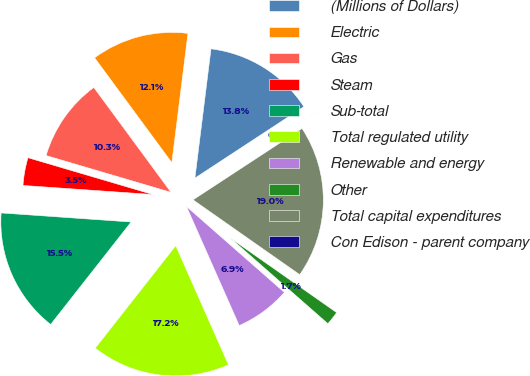Convert chart. <chart><loc_0><loc_0><loc_500><loc_500><pie_chart><fcel>(Millions of Dollars)<fcel>Electric<fcel>Gas<fcel>Steam<fcel>Sub-total<fcel>Total regulated utility<fcel>Renewable and energy<fcel>Other<fcel>Total capital expenditures<fcel>Con Edison - parent company<nl><fcel>13.79%<fcel>12.07%<fcel>10.34%<fcel>3.45%<fcel>15.51%<fcel>17.23%<fcel>6.9%<fcel>1.73%<fcel>18.96%<fcel>0.01%<nl></chart> 